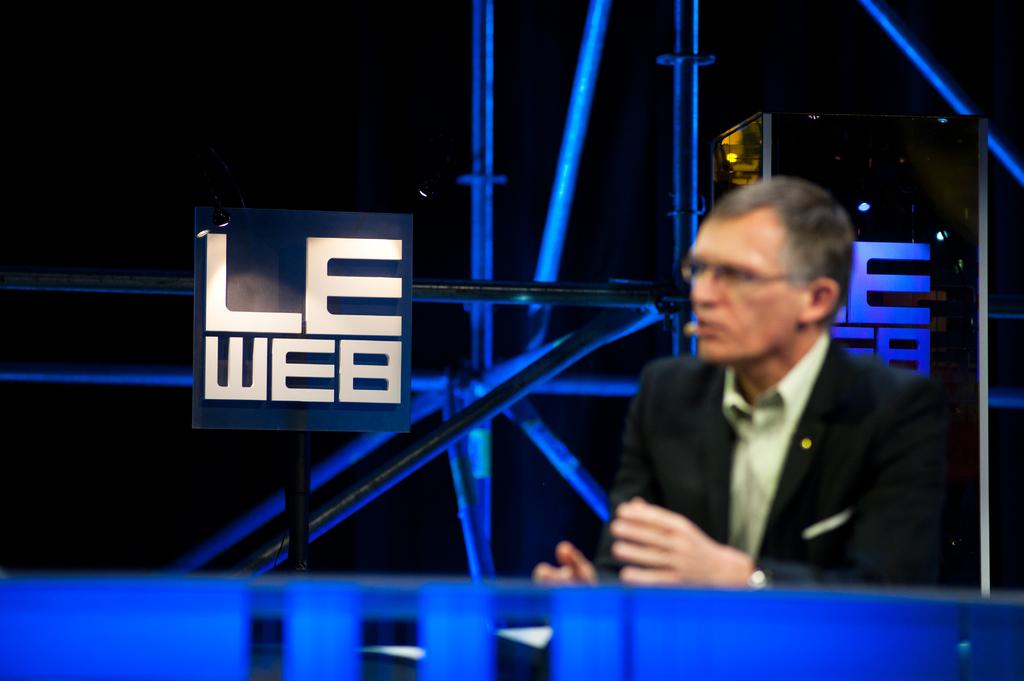What does the white logo say?
Keep it short and to the point. Le web. 